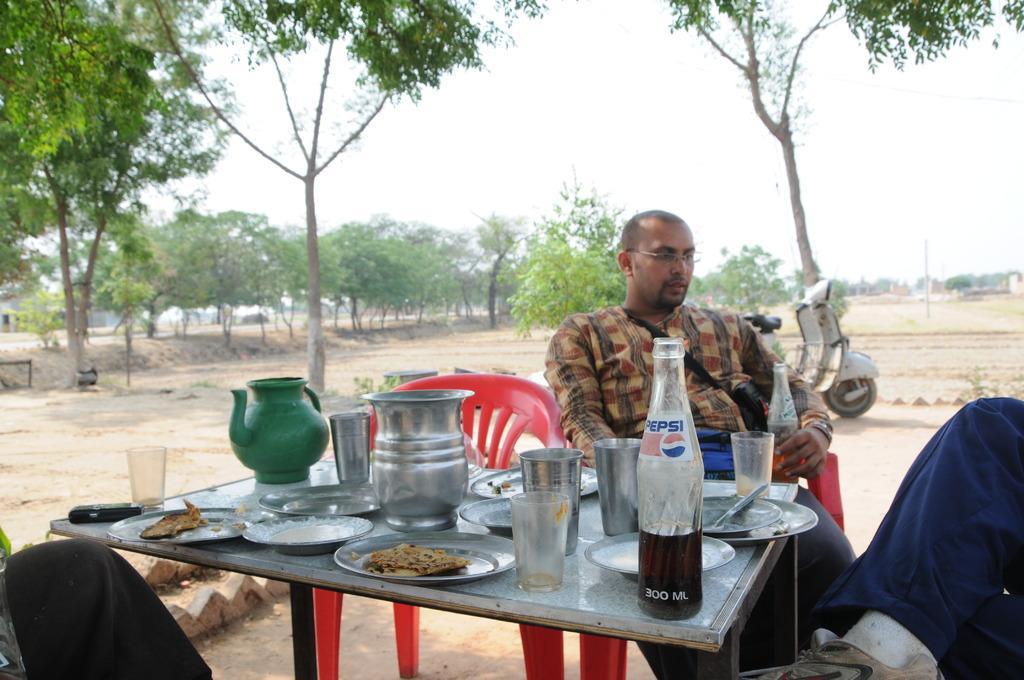In one or two sentences, can you explain what this image depicts? In this image I can see a person sitting in front of the table. On the table there is a plate with food,glass,bottle and the flask. At the back of him there is a scooter. In the background there are some trees and the sky. 